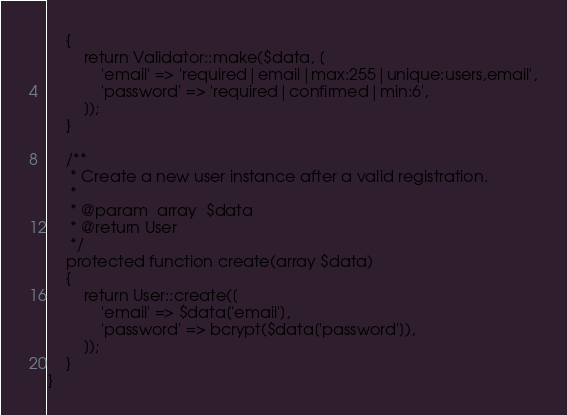Convert code to text. <code><loc_0><loc_0><loc_500><loc_500><_PHP_>    {
        return Validator::make($data, [
            'email' => 'required|email|max:255|unique:users,email',
            'password' => 'required|confirmed|min:6',
        ]);
    }

    /**
     * Create a new user instance after a valid registration.
     *
     * @param  array  $data
     * @return User
     */
    protected function create(array $data)
    {
        return User::create([
            'email' => $data['email'],
            'password' => bcrypt($data['password']),
        ]);
    }
}
</code> 